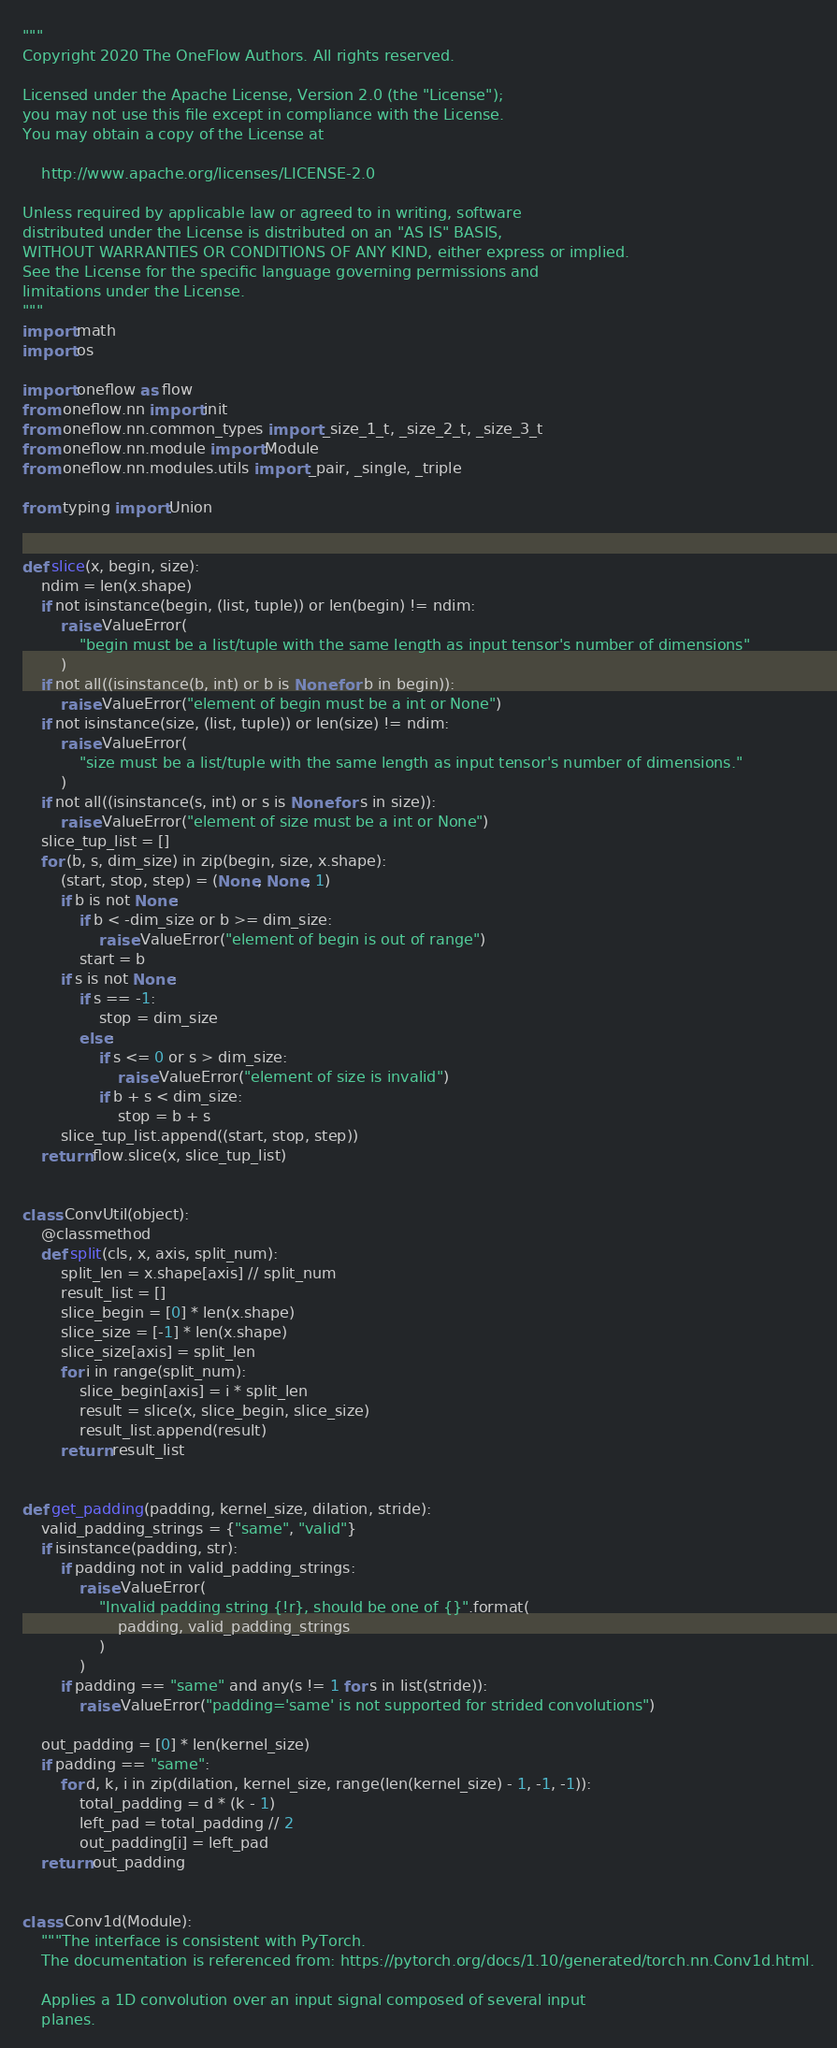<code> <loc_0><loc_0><loc_500><loc_500><_Python_>"""
Copyright 2020 The OneFlow Authors. All rights reserved.

Licensed under the Apache License, Version 2.0 (the "License");
you may not use this file except in compliance with the License.
You may obtain a copy of the License at

    http://www.apache.org/licenses/LICENSE-2.0

Unless required by applicable law or agreed to in writing, software
distributed under the License is distributed on an "AS IS" BASIS,
WITHOUT WARRANTIES OR CONDITIONS OF ANY KIND, either express or implied.
See the License for the specific language governing permissions and
limitations under the License.
"""
import math
import os

import oneflow as flow
from oneflow.nn import init
from oneflow.nn.common_types import _size_1_t, _size_2_t, _size_3_t
from oneflow.nn.module import Module
from oneflow.nn.modules.utils import _pair, _single, _triple

from typing import Union


def slice(x, begin, size):
    ndim = len(x.shape)
    if not isinstance(begin, (list, tuple)) or len(begin) != ndim:
        raise ValueError(
            "begin must be a list/tuple with the same length as input tensor's number of dimensions"
        )
    if not all((isinstance(b, int) or b is None for b in begin)):
        raise ValueError("element of begin must be a int or None")
    if not isinstance(size, (list, tuple)) or len(size) != ndim:
        raise ValueError(
            "size must be a list/tuple with the same length as input tensor's number of dimensions."
        )
    if not all((isinstance(s, int) or s is None for s in size)):
        raise ValueError("element of size must be a int or None")
    slice_tup_list = []
    for (b, s, dim_size) in zip(begin, size, x.shape):
        (start, stop, step) = (None, None, 1)
        if b is not None:
            if b < -dim_size or b >= dim_size:
                raise ValueError("element of begin is out of range")
            start = b
        if s is not None:
            if s == -1:
                stop = dim_size
            else:
                if s <= 0 or s > dim_size:
                    raise ValueError("element of size is invalid")
                if b + s < dim_size:
                    stop = b + s
        slice_tup_list.append((start, stop, step))
    return flow.slice(x, slice_tup_list)


class ConvUtil(object):
    @classmethod
    def split(cls, x, axis, split_num):
        split_len = x.shape[axis] // split_num
        result_list = []
        slice_begin = [0] * len(x.shape)
        slice_size = [-1] * len(x.shape)
        slice_size[axis] = split_len
        for i in range(split_num):
            slice_begin[axis] = i * split_len
            result = slice(x, slice_begin, slice_size)
            result_list.append(result)
        return result_list


def get_padding(padding, kernel_size, dilation, stride):
    valid_padding_strings = {"same", "valid"}
    if isinstance(padding, str):
        if padding not in valid_padding_strings:
            raise ValueError(
                "Invalid padding string {!r}, should be one of {}".format(
                    padding, valid_padding_strings
                )
            )
        if padding == "same" and any(s != 1 for s in list(stride)):
            raise ValueError("padding='same' is not supported for strided convolutions")

    out_padding = [0] * len(kernel_size)
    if padding == "same":
        for d, k, i in zip(dilation, kernel_size, range(len(kernel_size) - 1, -1, -1)):
            total_padding = d * (k - 1)
            left_pad = total_padding // 2
            out_padding[i] = left_pad
    return out_padding


class Conv1d(Module):
    """The interface is consistent with PyTorch.    
    The documentation is referenced from: https://pytorch.org/docs/1.10/generated/torch.nn.Conv1d.html.
    
    Applies a 1D convolution over an input signal composed of several input
    planes.
</code> 